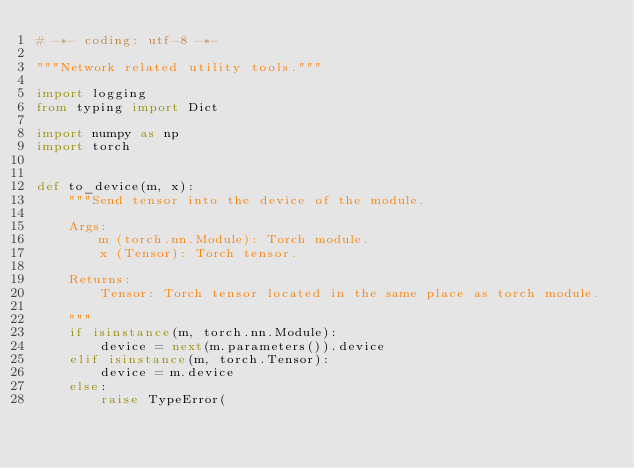<code> <loc_0><loc_0><loc_500><loc_500><_Python_># -*- coding: utf-8 -*-

"""Network related utility tools."""

import logging
from typing import Dict

import numpy as np
import torch


def to_device(m, x):
    """Send tensor into the device of the module.

    Args:
        m (torch.nn.Module): Torch module.
        x (Tensor): Torch tensor.

    Returns:
        Tensor: Torch tensor located in the same place as torch module.

    """
    if isinstance(m, torch.nn.Module):
        device = next(m.parameters()).device
    elif isinstance(m, torch.Tensor):
        device = m.device
    else:
        raise TypeError(</code> 